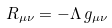Convert formula to latex. <formula><loc_0><loc_0><loc_500><loc_500>R _ { \mu \nu } = - \Lambda \, g _ { \mu \nu }</formula> 